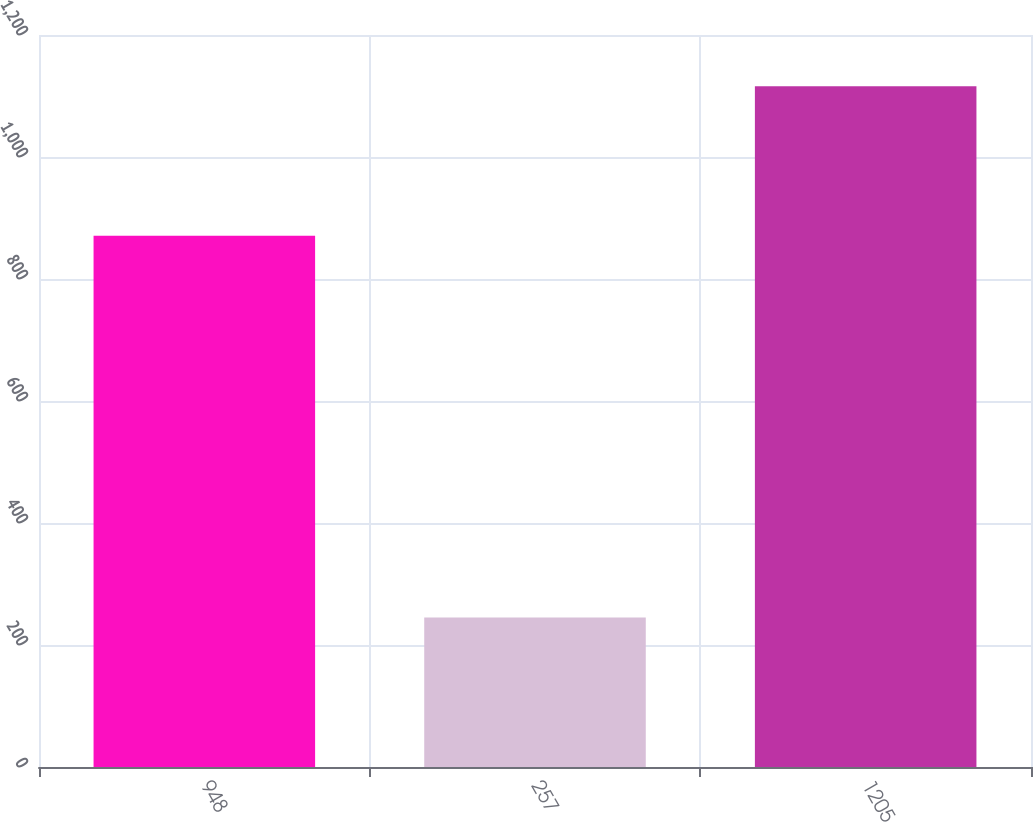Convert chart. <chart><loc_0><loc_0><loc_500><loc_500><bar_chart><fcel>948<fcel>257<fcel>1205<nl><fcel>871<fcel>245<fcel>1116<nl></chart> 